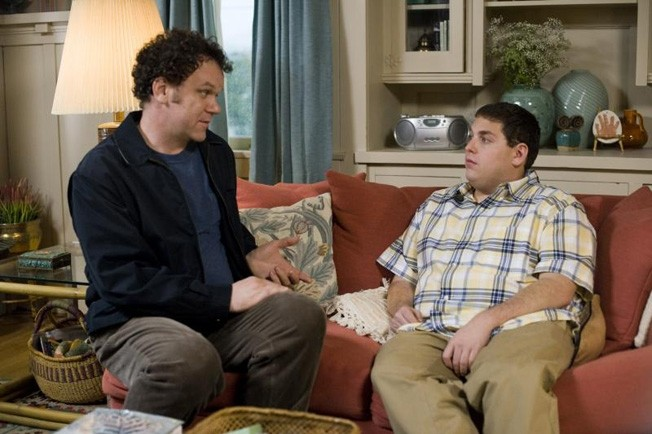What might these characters be discussing, given their body language and expressions? The characters, portrayed by John C. Reilly and Jonah Hill, appear to be deeply involved in a serious conversation, likely about personal or familial issues that are central to the plot of 'Cyrus'. The intense eye contact and the reserved body posture of Jonah Hill, contrasted with the more relaxed posture of John C. Reilly, suggest a dynamic where one character is seeking approval or understanding from the other. How does the setting of this scene contribute to the overall atmosphere? The cozy living room setting, with soft lighting and warm colors, creates an atmosphere of intimacy and safety, which contrasts with the potential tension in the conversation. This juxtaposition might serve to highlight the complexity of human relationships and the notion of private issues clashing within a safe environment. 